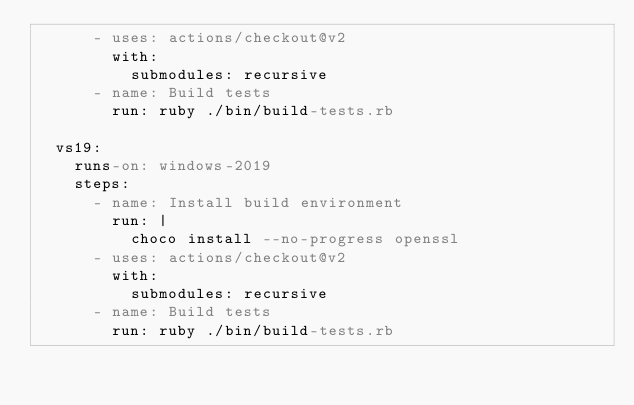<code> <loc_0><loc_0><loc_500><loc_500><_YAML_>      - uses: actions/checkout@v2
        with:
          submodules: recursive
      - name: Build tests
        run: ruby ./bin/build-tests.rb

  vs19:
    runs-on: windows-2019
    steps:
      - name: Install build environment
        run: |
          choco install --no-progress openssl
      - uses: actions/checkout@v2
        with:
          submodules: recursive
      - name: Build tests
        run: ruby ./bin/build-tests.rb
</code> 